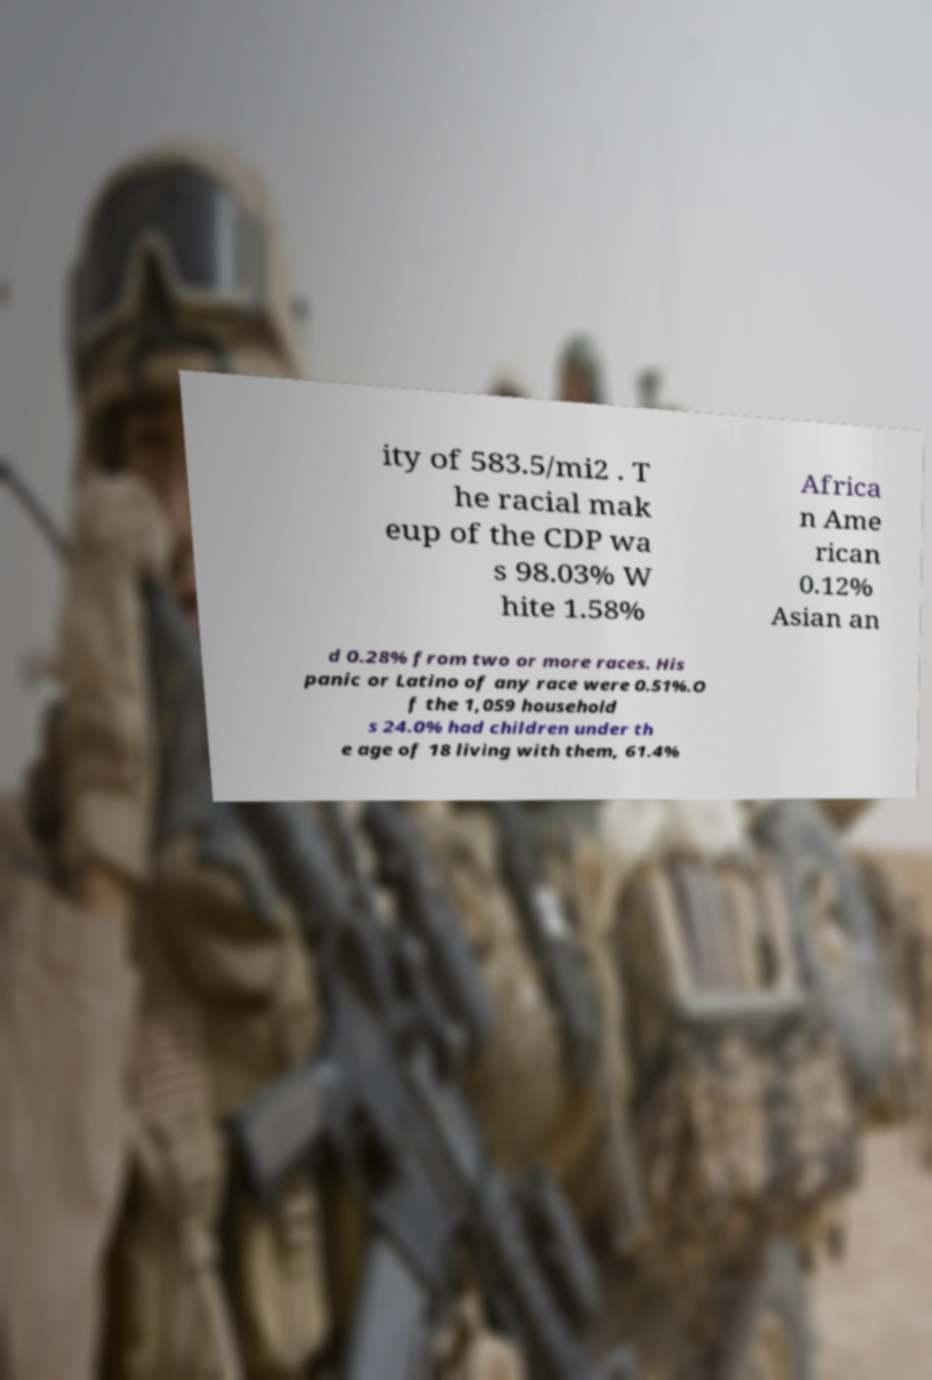I need the written content from this picture converted into text. Can you do that? ity of 583.5/mi2 . T he racial mak eup of the CDP wa s 98.03% W hite 1.58% Africa n Ame rican 0.12% Asian an d 0.28% from two or more races. His panic or Latino of any race were 0.51%.O f the 1,059 household s 24.0% had children under th e age of 18 living with them, 61.4% 